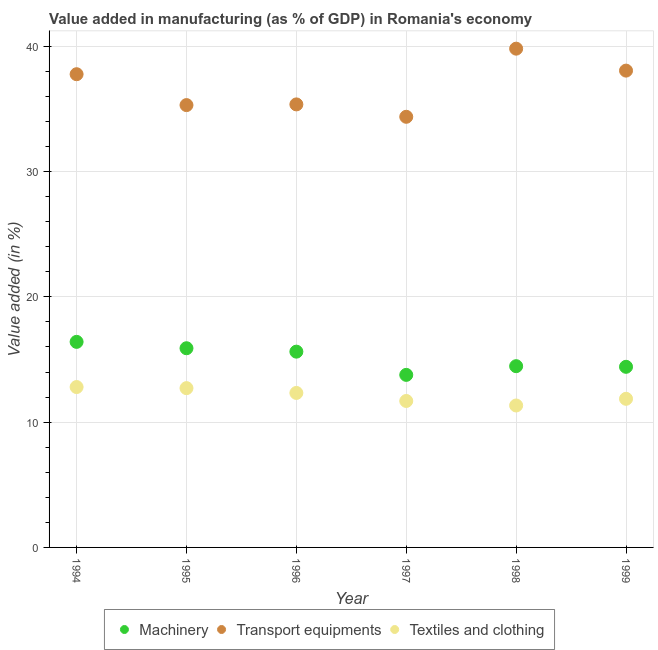What is the value added in manufacturing machinery in 1994?
Make the answer very short. 16.4. Across all years, what is the maximum value added in manufacturing machinery?
Provide a succinct answer. 16.4. Across all years, what is the minimum value added in manufacturing transport equipments?
Provide a short and direct response. 34.37. In which year was the value added in manufacturing textile and clothing maximum?
Offer a terse response. 1994. What is the total value added in manufacturing textile and clothing in the graph?
Your answer should be very brief. 72.72. What is the difference between the value added in manufacturing textile and clothing in 1996 and that in 1997?
Keep it short and to the point. 0.64. What is the difference between the value added in manufacturing transport equipments in 1998 and the value added in manufacturing machinery in 1995?
Offer a terse response. 23.91. What is the average value added in manufacturing machinery per year?
Give a very brief answer. 15.1. In the year 1997, what is the difference between the value added in manufacturing textile and clothing and value added in manufacturing machinery?
Keep it short and to the point. -2.08. In how many years, is the value added in manufacturing machinery greater than 12 %?
Give a very brief answer. 6. What is the ratio of the value added in manufacturing textile and clothing in 1994 to that in 1999?
Offer a very short reply. 1.08. Is the value added in manufacturing machinery in 1996 less than that in 1999?
Provide a short and direct response. No. Is the difference between the value added in manufacturing machinery in 1997 and 1998 greater than the difference between the value added in manufacturing transport equipments in 1997 and 1998?
Provide a short and direct response. Yes. What is the difference between the highest and the second highest value added in manufacturing textile and clothing?
Make the answer very short. 0.09. What is the difference between the highest and the lowest value added in manufacturing transport equipments?
Provide a short and direct response. 5.44. In how many years, is the value added in manufacturing machinery greater than the average value added in manufacturing machinery taken over all years?
Your answer should be compact. 3. Is the sum of the value added in manufacturing machinery in 1996 and 1999 greater than the maximum value added in manufacturing textile and clothing across all years?
Offer a terse response. Yes. How many years are there in the graph?
Keep it short and to the point. 6. What is the difference between two consecutive major ticks on the Y-axis?
Provide a succinct answer. 10. Are the values on the major ticks of Y-axis written in scientific E-notation?
Your answer should be very brief. No. Does the graph contain any zero values?
Make the answer very short. No. Where does the legend appear in the graph?
Make the answer very short. Bottom center. How many legend labels are there?
Offer a terse response. 3. What is the title of the graph?
Your answer should be compact. Value added in manufacturing (as % of GDP) in Romania's economy. Does "Coal sources" appear as one of the legend labels in the graph?
Your answer should be compact. No. What is the label or title of the Y-axis?
Provide a short and direct response. Value added (in %). What is the Value added (in %) of Machinery in 1994?
Ensure brevity in your answer.  16.4. What is the Value added (in %) in Transport equipments in 1994?
Offer a very short reply. 37.77. What is the Value added (in %) of Textiles and clothing in 1994?
Provide a succinct answer. 12.8. What is the Value added (in %) in Machinery in 1995?
Your answer should be compact. 15.9. What is the Value added (in %) of Transport equipments in 1995?
Make the answer very short. 35.3. What is the Value added (in %) in Textiles and clothing in 1995?
Offer a very short reply. 12.71. What is the Value added (in %) in Machinery in 1996?
Offer a terse response. 15.62. What is the Value added (in %) of Transport equipments in 1996?
Make the answer very short. 35.36. What is the Value added (in %) in Textiles and clothing in 1996?
Give a very brief answer. 12.33. What is the Value added (in %) of Machinery in 1997?
Offer a very short reply. 13.77. What is the Value added (in %) of Transport equipments in 1997?
Offer a terse response. 34.37. What is the Value added (in %) of Textiles and clothing in 1997?
Your response must be concise. 11.69. What is the Value added (in %) of Machinery in 1998?
Provide a succinct answer. 14.47. What is the Value added (in %) of Transport equipments in 1998?
Offer a terse response. 39.8. What is the Value added (in %) of Textiles and clothing in 1998?
Keep it short and to the point. 11.33. What is the Value added (in %) of Machinery in 1999?
Offer a very short reply. 14.41. What is the Value added (in %) of Transport equipments in 1999?
Your answer should be compact. 38.05. What is the Value added (in %) in Textiles and clothing in 1999?
Offer a terse response. 11.86. Across all years, what is the maximum Value added (in %) of Machinery?
Provide a short and direct response. 16.4. Across all years, what is the maximum Value added (in %) of Transport equipments?
Provide a succinct answer. 39.8. Across all years, what is the maximum Value added (in %) in Textiles and clothing?
Offer a terse response. 12.8. Across all years, what is the minimum Value added (in %) of Machinery?
Offer a very short reply. 13.77. Across all years, what is the minimum Value added (in %) in Transport equipments?
Offer a very short reply. 34.37. Across all years, what is the minimum Value added (in %) in Textiles and clothing?
Your answer should be compact. 11.33. What is the total Value added (in %) in Machinery in the graph?
Your response must be concise. 90.57. What is the total Value added (in %) in Transport equipments in the graph?
Provide a short and direct response. 220.64. What is the total Value added (in %) of Textiles and clothing in the graph?
Make the answer very short. 72.72. What is the difference between the Value added (in %) in Machinery in 1994 and that in 1995?
Give a very brief answer. 0.51. What is the difference between the Value added (in %) of Transport equipments in 1994 and that in 1995?
Provide a succinct answer. 2.46. What is the difference between the Value added (in %) of Textiles and clothing in 1994 and that in 1995?
Provide a short and direct response. 0.09. What is the difference between the Value added (in %) of Machinery in 1994 and that in 1996?
Your answer should be very brief. 0.78. What is the difference between the Value added (in %) in Transport equipments in 1994 and that in 1996?
Offer a terse response. 2.41. What is the difference between the Value added (in %) in Textiles and clothing in 1994 and that in 1996?
Ensure brevity in your answer.  0.47. What is the difference between the Value added (in %) in Machinery in 1994 and that in 1997?
Your response must be concise. 2.63. What is the difference between the Value added (in %) in Transport equipments in 1994 and that in 1997?
Provide a short and direct response. 3.4. What is the difference between the Value added (in %) of Textiles and clothing in 1994 and that in 1997?
Give a very brief answer. 1.11. What is the difference between the Value added (in %) in Machinery in 1994 and that in 1998?
Your answer should be compact. 1.94. What is the difference between the Value added (in %) in Transport equipments in 1994 and that in 1998?
Your answer should be very brief. -2.04. What is the difference between the Value added (in %) of Textiles and clothing in 1994 and that in 1998?
Provide a short and direct response. 1.47. What is the difference between the Value added (in %) of Machinery in 1994 and that in 1999?
Your answer should be compact. 1.99. What is the difference between the Value added (in %) of Transport equipments in 1994 and that in 1999?
Your answer should be very brief. -0.29. What is the difference between the Value added (in %) of Textiles and clothing in 1994 and that in 1999?
Give a very brief answer. 0.94. What is the difference between the Value added (in %) in Machinery in 1995 and that in 1996?
Offer a terse response. 0.27. What is the difference between the Value added (in %) in Transport equipments in 1995 and that in 1996?
Keep it short and to the point. -0.06. What is the difference between the Value added (in %) of Textiles and clothing in 1995 and that in 1996?
Ensure brevity in your answer.  0.38. What is the difference between the Value added (in %) of Machinery in 1995 and that in 1997?
Offer a very short reply. 2.13. What is the difference between the Value added (in %) in Textiles and clothing in 1995 and that in 1997?
Make the answer very short. 1.02. What is the difference between the Value added (in %) of Machinery in 1995 and that in 1998?
Your response must be concise. 1.43. What is the difference between the Value added (in %) in Transport equipments in 1995 and that in 1998?
Keep it short and to the point. -4.5. What is the difference between the Value added (in %) of Textiles and clothing in 1995 and that in 1998?
Keep it short and to the point. 1.38. What is the difference between the Value added (in %) of Machinery in 1995 and that in 1999?
Ensure brevity in your answer.  1.48. What is the difference between the Value added (in %) in Transport equipments in 1995 and that in 1999?
Make the answer very short. -2.75. What is the difference between the Value added (in %) in Textiles and clothing in 1995 and that in 1999?
Keep it short and to the point. 0.85. What is the difference between the Value added (in %) of Machinery in 1996 and that in 1997?
Your response must be concise. 1.85. What is the difference between the Value added (in %) of Transport equipments in 1996 and that in 1997?
Offer a terse response. 0.99. What is the difference between the Value added (in %) of Textiles and clothing in 1996 and that in 1997?
Make the answer very short. 0.64. What is the difference between the Value added (in %) in Machinery in 1996 and that in 1998?
Your response must be concise. 1.16. What is the difference between the Value added (in %) of Transport equipments in 1996 and that in 1998?
Ensure brevity in your answer.  -4.45. What is the difference between the Value added (in %) of Machinery in 1996 and that in 1999?
Provide a short and direct response. 1.21. What is the difference between the Value added (in %) of Transport equipments in 1996 and that in 1999?
Offer a very short reply. -2.7. What is the difference between the Value added (in %) of Textiles and clothing in 1996 and that in 1999?
Your answer should be very brief. 0.47. What is the difference between the Value added (in %) of Machinery in 1997 and that in 1998?
Ensure brevity in your answer.  -0.69. What is the difference between the Value added (in %) in Transport equipments in 1997 and that in 1998?
Ensure brevity in your answer.  -5.44. What is the difference between the Value added (in %) of Textiles and clothing in 1997 and that in 1998?
Keep it short and to the point. 0.36. What is the difference between the Value added (in %) of Machinery in 1997 and that in 1999?
Ensure brevity in your answer.  -0.64. What is the difference between the Value added (in %) in Transport equipments in 1997 and that in 1999?
Give a very brief answer. -3.68. What is the difference between the Value added (in %) in Textiles and clothing in 1997 and that in 1999?
Your response must be concise. -0.17. What is the difference between the Value added (in %) in Machinery in 1998 and that in 1999?
Offer a terse response. 0.05. What is the difference between the Value added (in %) in Transport equipments in 1998 and that in 1999?
Your answer should be compact. 1.75. What is the difference between the Value added (in %) of Textiles and clothing in 1998 and that in 1999?
Ensure brevity in your answer.  -0.53. What is the difference between the Value added (in %) in Machinery in 1994 and the Value added (in %) in Transport equipments in 1995?
Your answer should be compact. -18.9. What is the difference between the Value added (in %) in Machinery in 1994 and the Value added (in %) in Textiles and clothing in 1995?
Your response must be concise. 3.69. What is the difference between the Value added (in %) in Transport equipments in 1994 and the Value added (in %) in Textiles and clothing in 1995?
Offer a terse response. 25.05. What is the difference between the Value added (in %) of Machinery in 1994 and the Value added (in %) of Transport equipments in 1996?
Make the answer very short. -18.95. What is the difference between the Value added (in %) in Machinery in 1994 and the Value added (in %) in Textiles and clothing in 1996?
Offer a very short reply. 4.08. What is the difference between the Value added (in %) of Transport equipments in 1994 and the Value added (in %) of Textiles and clothing in 1996?
Your response must be concise. 25.44. What is the difference between the Value added (in %) in Machinery in 1994 and the Value added (in %) in Transport equipments in 1997?
Offer a very short reply. -17.96. What is the difference between the Value added (in %) of Machinery in 1994 and the Value added (in %) of Textiles and clothing in 1997?
Keep it short and to the point. 4.72. What is the difference between the Value added (in %) of Transport equipments in 1994 and the Value added (in %) of Textiles and clothing in 1997?
Offer a very short reply. 26.08. What is the difference between the Value added (in %) of Machinery in 1994 and the Value added (in %) of Transport equipments in 1998?
Ensure brevity in your answer.  -23.4. What is the difference between the Value added (in %) of Machinery in 1994 and the Value added (in %) of Textiles and clothing in 1998?
Offer a terse response. 5.08. What is the difference between the Value added (in %) of Transport equipments in 1994 and the Value added (in %) of Textiles and clothing in 1998?
Ensure brevity in your answer.  26.44. What is the difference between the Value added (in %) of Machinery in 1994 and the Value added (in %) of Transport equipments in 1999?
Provide a succinct answer. -21.65. What is the difference between the Value added (in %) of Machinery in 1994 and the Value added (in %) of Textiles and clothing in 1999?
Your answer should be very brief. 4.54. What is the difference between the Value added (in %) of Transport equipments in 1994 and the Value added (in %) of Textiles and clothing in 1999?
Your answer should be compact. 25.9. What is the difference between the Value added (in %) in Machinery in 1995 and the Value added (in %) in Transport equipments in 1996?
Your answer should be very brief. -19.46. What is the difference between the Value added (in %) of Machinery in 1995 and the Value added (in %) of Textiles and clothing in 1996?
Give a very brief answer. 3.57. What is the difference between the Value added (in %) in Transport equipments in 1995 and the Value added (in %) in Textiles and clothing in 1996?
Provide a succinct answer. 22.97. What is the difference between the Value added (in %) of Machinery in 1995 and the Value added (in %) of Transport equipments in 1997?
Provide a short and direct response. -18.47. What is the difference between the Value added (in %) of Machinery in 1995 and the Value added (in %) of Textiles and clothing in 1997?
Your response must be concise. 4.21. What is the difference between the Value added (in %) in Transport equipments in 1995 and the Value added (in %) in Textiles and clothing in 1997?
Your answer should be very brief. 23.61. What is the difference between the Value added (in %) in Machinery in 1995 and the Value added (in %) in Transport equipments in 1998?
Your answer should be very brief. -23.91. What is the difference between the Value added (in %) of Machinery in 1995 and the Value added (in %) of Textiles and clothing in 1998?
Ensure brevity in your answer.  4.57. What is the difference between the Value added (in %) in Transport equipments in 1995 and the Value added (in %) in Textiles and clothing in 1998?
Make the answer very short. 23.97. What is the difference between the Value added (in %) of Machinery in 1995 and the Value added (in %) of Transport equipments in 1999?
Your answer should be compact. -22.16. What is the difference between the Value added (in %) in Machinery in 1995 and the Value added (in %) in Textiles and clothing in 1999?
Offer a terse response. 4.04. What is the difference between the Value added (in %) in Transport equipments in 1995 and the Value added (in %) in Textiles and clothing in 1999?
Offer a very short reply. 23.44. What is the difference between the Value added (in %) in Machinery in 1996 and the Value added (in %) in Transport equipments in 1997?
Offer a terse response. -18.74. What is the difference between the Value added (in %) in Machinery in 1996 and the Value added (in %) in Textiles and clothing in 1997?
Your answer should be very brief. 3.94. What is the difference between the Value added (in %) of Transport equipments in 1996 and the Value added (in %) of Textiles and clothing in 1997?
Your answer should be compact. 23.67. What is the difference between the Value added (in %) in Machinery in 1996 and the Value added (in %) in Transport equipments in 1998?
Your answer should be compact. -24.18. What is the difference between the Value added (in %) of Machinery in 1996 and the Value added (in %) of Textiles and clothing in 1998?
Ensure brevity in your answer.  4.3. What is the difference between the Value added (in %) of Transport equipments in 1996 and the Value added (in %) of Textiles and clothing in 1998?
Your answer should be compact. 24.03. What is the difference between the Value added (in %) of Machinery in 1996 and the Value added (in %) of Transport equipments in 1999?
Ensure brevity in your answer.  -22.43. What is the difference between the Value added (in %) of Machinery in 1996 and the Value added (in %) of Textiles and clothing in 1999?
Give a very brief answer. 3.76. What is the difference between the Value added (in %) of Transport equipments in 1996 and the Value added (in %) of Textiles and clothing in 1999?
Provide a succinct answer. 23.49. What is the difference between the Value added (in %) in Machinery in 1997 and the Value added (in %) in Transport equipments in 1998?
Offer a very short reply. -26.03. What is the difference between the Value added (in %) in Machinery in 1997 and the Value added (in %) in Textiles and clothing in 1998?
Offer a terse response. 2.44. What is the difference between the Value added (in %) of Transport equipments in 1997 and the Value added (in %) of Textiles and clothing in 1998?
Provide a succinct answer. 23.04. What is the difference between the Value added (in %) in Machinery in 1997 and the Value added (in %) in Transport equipments in 1999?
Offer a very short reply. -24.28. What is the difference between the Value added (in %) in Machinery in 1997 and the Value added (in %) in Textiles and clothing in 1999?
Your answer should be very brief. 1.91. What is the difference between the Value added (in %) in Transport equipments in 1997 and the Value added (in %) in Textiles and clothing in 1999?
Ensure brevity in your answer.  22.51. What is the difference between the Value added (in %) in Machinery in 1998 and the Value added (in %) in Transport equipments in 1999?
Provide a succinct answer. -23.59. What is the difference between the Value added (in %) in Machinery in 1998 and the Value added (in %) in Textiles and clothing in 1999?
Keep it short and to the point. 2.6. What is the difference between the Value added (in %) of Transport equipments in 1998 and the Value added (in %) of Textiles and clothing in 1999?
Provide a short and direct response. 27.94. What is the average Value added (in %) of Machinery per year?
Make the answer very short. 15.1. What is the average Value added (in %) of Transport equipments per year?
Give a very brief answer. 36.77. What is the average Value added (in %) in Textiles and clothing per year?
Your answer should be very brief. 12.12. In the year 1994, what is the difference between the Value added (in %) of Machinery and Value added (in %) of Transport equipments?
Make the answer very short. -21.36. In the year 1994, what is the difference between the Value added (in %) in Machinery and Value added (in %) in Textiles and clothing?
Your answer should be compact. 3.61. In the year 1994, what is the difference between the Value added (in %) in Transport equipments and Value added (in %) in Textiles and clothing?
Give a very brief answer. 24.97. In the year 1995, what is the difference between the Value added (in %) of Machinery and Value added (in %) of Transport equipments?
Keep it short and to the point. -19.4. In the year 1995, what is the difference between the Value added (in %) in Machinery and Value added (in %) in Textiles and clothing?
Give a very brief answer. 3.18. In the year 1995, what is the difference between the Value added (in %) of Transport equipments and Value added (in %) of Textiles and clothing?
Make the answer very short. 22.59. In the year 1996, what is the difference between the Value added (in %) of Machinery and Value added (in %) of Transport equipments?
Offer a terse response. -19.73. In the year 1996, what is the difference between the Value added (in %) in Machinery and Value added (in %) in Textiles and clothing?
Provide a succinct answer. 3.29. In the year 1996, what is the difference between the Value added (in %) in Transport equipments and Value added (in %) in Textiles and clothing?
Offer a terse response. 23.03. In the year 1997, what is the difference between the Value added (in %) in Machinery and Value added (in %) in Transport equipments?
Your answer should be compact. -20.6. In the year 1997, what is the difference between the Value added (in %) of Machinery and Value added (in %) of Textiles and clothing?
Keep it short and to the point. 2.08. In the year 1997, what is the difference between the Value added (in %) in Transport equipments and Value added (in %) in Textiles and clothing?
Your answer should be compact. 22.68. In the year 1998, what is the difference between the Value added (in %) of Machinery and Value added (in %) of Transport equipments?
Provide a succinct answer. -25.34. In the year 1998, what is the difference between the Value added (in %) in Machinery and Value added (in %) in Textiles and clothing?
Keep it short and to the point. 3.14. In the year 1998, what is the difference between the Value added (in %) of Transport equipments and Value added (in %) of Textiles and clothing?
Offer a very short reply. 28.48. In the year 1999, what is the difference between the Value added (in %) in Machinery and Value added (in %) in Transport equipments?
Ensure brevity in your answer.  -23.64. In the year 1999, what is the difference between the Value added (in %) of Machinery and Value added (in %) of Textiles and clothing?
Offer a very short reply. 2.55. In the year 1999, what is the difference between the Value added (in %) in Transport equipments and Value added (in %) in Textiles and clothing?
Provide a short and direct response. 26.19. What is the ratio of the Value added (in %) of Machinery in 1994 to that in 1995?
Ensure brevity in your answer.  1.03. What is the ratio of the Value added (in %) of Transport equipments in 1994 to that in 1995?
Your response must be concise. 1.07. What is the ratio of the Value added (in %) in Textiles and clothing in 1994 to that in 1995?
Make the answer very short. 1.01. What is the ratio of the Value added (in %) of Transport equipments in 1994 to that in 1996?
Provide a succinct answer. 1.07. What is the ratio of the Value added (in %) of Textiles and clothing in 1994 to that in 1996?
Offer a terse response. 1.04. What is the ratio of the Value added (in %) of Machinery in 1994 to that in 1997?
Provide a short and direct response. 1.19. What is the ratio of the Value added (in %) of Transport equipments in 1994 to that in 1997?
Keep it short and to the point. 1.1. What is the ratio of the Value added (in %) of Textiles and clothing in 1994 to that in 1997?
Provide a short and direct response. 1.1. What is the ratio of the Value added (in %) of Machinery in 1994 to that in 1998?
Keep it short and to the point. 1.13. What is the ratio of the Value added (in %) of Transport equipments in 1994 to that in 1998?
Your answer should be very brief. 0.95. What is the ratio of the Value added (in %) of Textiles and clothing in 1994 to that in 1998?
Ensure brevity in your answer.  1.13. What is the ratio of the Value added (in %) of Machinery in 1994 to that in 1999?
Your response must be concise. 1.14. What is the ratio of the Value added (in %) of Textiles and clothing in 1994 to that in 1999?
Provide a succinct answer. 1.08. What is the ratio of the Value added (in %) of Machinery in 1995 to that in 1996?
Keep it short and to the point. 1.02. What is the ratio of the Value added (in %) in Textiles and clothing in 1995 to that in 1996?
Keep it short and to the point. 1.03. What is the ratio of the Value added (in %) of Machinery in 1995 to that in 1997?
Your answer should be very brief. 1.15. What is the ratio of the Value added (in %) of Transport equipments in 1995 to that in 1997?
Your answer should be compact. 1.03. What is the ratio of the Value added (in %) in Textiles and clothing in 1995 to that in 1997?
Ensure brevity in your answer.  1.09. What is the ratio of the Value added (in %) in Machinery in 1995 to that in 1998?
Ensure brevity in your answer.  1.1. What is the ratio of the Value added (in %) of Transport equipments in 1995 to that in 1998?
Give a very brief answer. 0.89. What is the ratio of the Value added (in %) of Textiles and clothing in 1995 to that in 1998?
Your answer should be compact. 1.12. What is the ratio of the Value added (in %) in Machinery in 1995 to that in 1999?
Your answer should be compact. 1.1. What is the ratio of the Value added (in %) of Transport equipments in 1995 to that in 1999?
Your answer should be very brief. 0.93. What is the ratio of the Value added (in %) in Textiles and clothing in 1995 to that in 1999?
Provide a succinct answer. 1.07. What is the ratio of the Value added (in %) in Machinery in 1996 to that in 1997?
Provide a short and direct response. 1.13. What is the ratio of the Value added (in %) in Transport equipments in 1996 to that in 1997?
Offer a terse response. 1.03. What is the ratio of the Value added (in %) of Textiles and clothing in 1996 to that in 1997?
Make the answer very short. 1.05. What is the ratio of the Value added (in %) in Machinery in 1996 to that in 1998?
Offer a terse response. 1.08. What is the ratio of the Value added (in %) in Transport equipments in 1996 to that in 1998?
Offer a terse response. 0.89. What is the ratio of the Value added (in %) in Textiles and clothing in 1996 to that in 1998?
Ensure brevity in your answer.  1.09. What is the ratio of the Value added (in %) of Machinery in 1996 to that in 1999?
Your answer should be compact. 1.08. What is the ratio of the Value added (in %) in Transport equipments in 1996 to that in 1999?
Ensure brevity in your answer.  0.93. What is the ratio of the Value added (in %) of Textiles and clothing in 1996 to that in 1999?
Keep it short and to the point. 1.04. What is the ratio of the Value added (in %) in Transport equipments in 1997 to that in 1998?
Offer a very short reply. 0.86. What is the ratio of the Value added (in %) of Textiles and clothing in 1997 to that in 1998?
Offer a terse response. 1.03. What is the ratio of the Value added (in %) of Machinery in 1997 to that in 1999?
Offer a terse response. 0.96. What is the ratio of the Value added (in %) of Transport equipments in 1997 to that in 1999?
Offer a very short reply. 0.9. What is the ratio of the Value added (in %) in Textiles and clothing in 1997 to that in 1999?
Provide a short and direct response. 0.99. What is the ratio of the Value added (in %) in Transport equipments in 1998 to that in 1999?
Keep it short and to the point. 1.05. What is the ratio of the Value added (in %) in Textiles and clothing in 1998 to that in 1999?
Your answer should be compact. 0.95. What is the difference between the highest and the second highest Value added (in %) of Machinery?
Provide a succinct answer. 0.51. What is the difference between the highest and the second highest Value added (in %) of Transport equipments?
Your answer should be compact. 1.75. What is the difference between the highest and the second highest Value added (in %) of Textiles and clothing?
Keep it short and to the point. 0.09. What is the difference between the highest and the lowest Value added (in %) of Machinery?
Provide a short and direct response. 2.63. What is the difference between the highest and the lowest Value added (in %) in Transport equipments?
Offer a terse response. 5.44. What is the difference between the highest and the lowest Value added (in %) in Textiles and clothing?
Make the answer very short. 1.47. 